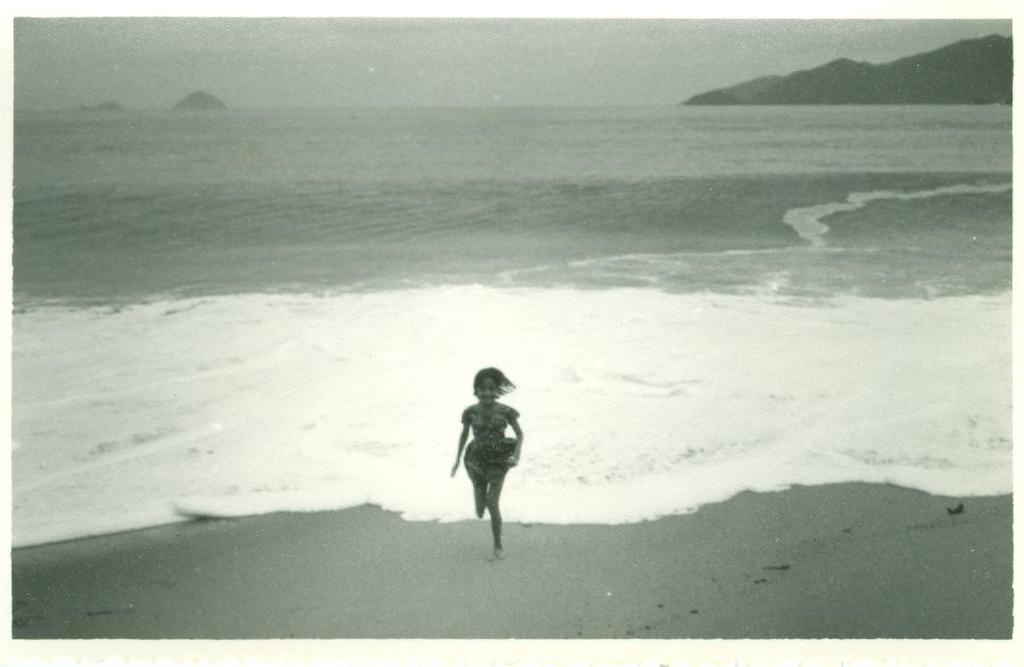What is the girl in the image doing? The girl is running in the image. What can be seen in the background of the image? There is water visible in the image. What type of terrain is present in the image? There is a hill in the image. What type of drain is visible in the image? There is no drain present in the image. How does the tramp contribute to the girl's running in the image? There is no tramp present in the image, so it cannot contribute to the girl's running. 